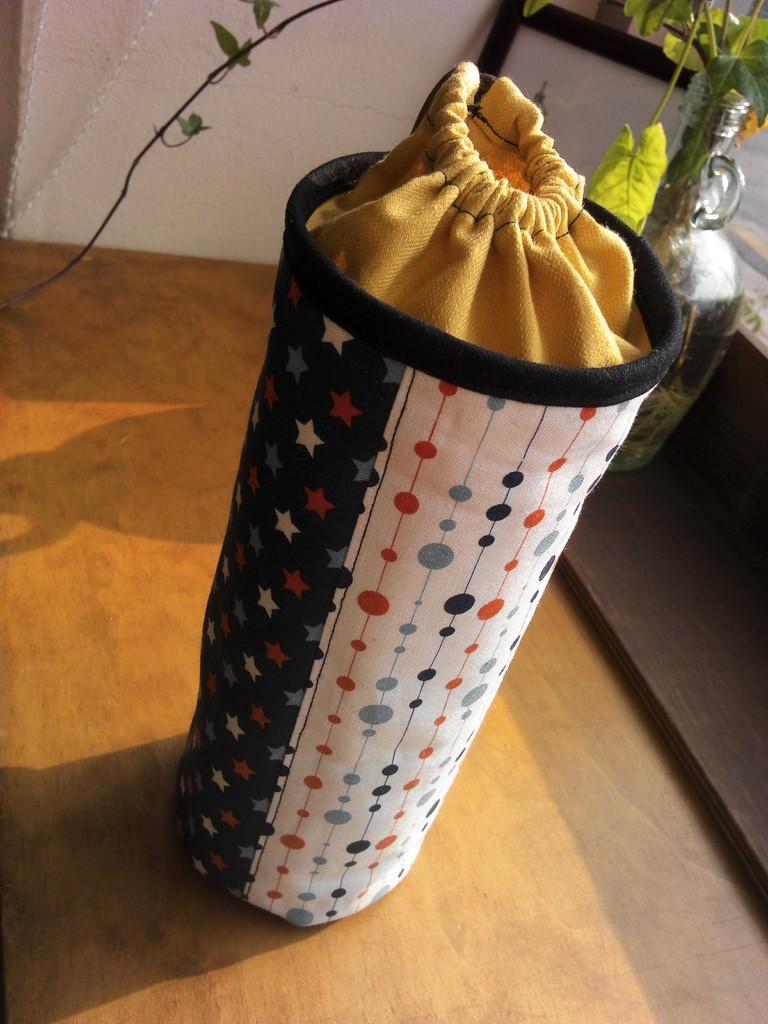In one or two sentences, can you explain what this image depicts? in this image we can see a sack in the pouch, creepers in the glass pot and walls. 